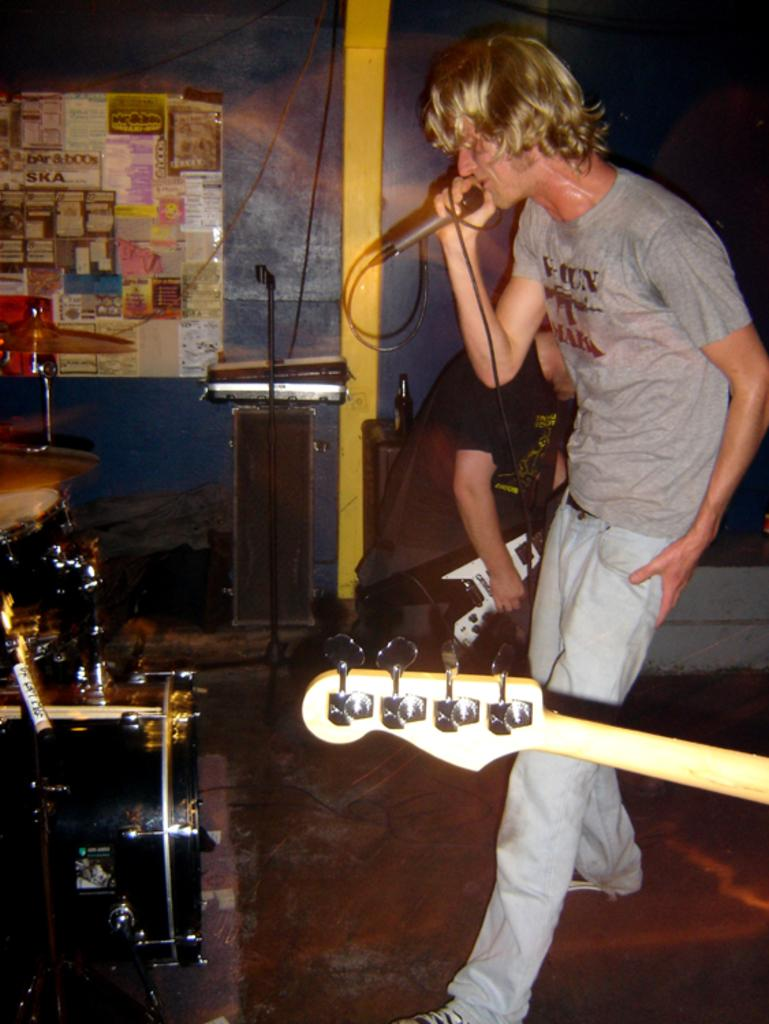What is the man in the image doing? The man is singing on a mic. What can be seen in the background of the image? Musical instruments and a wall are present in the background. Can you describe the person in the background? The person in the background is holding a guitar. What type of picture is hanging on the wall in the image? There is no picture hanging on the wall in the image; only musical instruments and a wall are present. Can you describe the rod used by the man to hold the microphone? There is no rod visible in the image; the man is holding a microphone directly. 